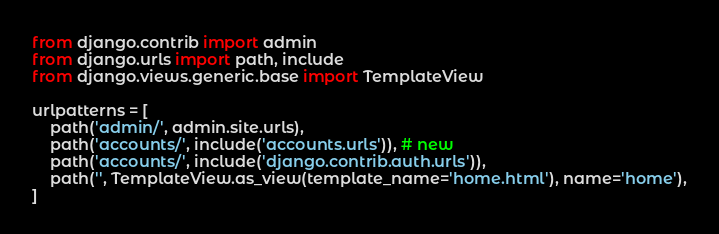<code> <loc_0><loc_0><loc_500><loc_500><_Python_>from django.contrib import admin
from django.urls import path, include
from django.views.generic.base import TemplateView

urlpatterns = [
    path('admin/', admin.site.urls),
    path('accounts/', include('accounts.urls')), # new
    path('accounts/', include('django.contrib.auth.urls')),
    path('', TemplateView.as_view(template_name='home.html'), name='home'),
]
</code> 